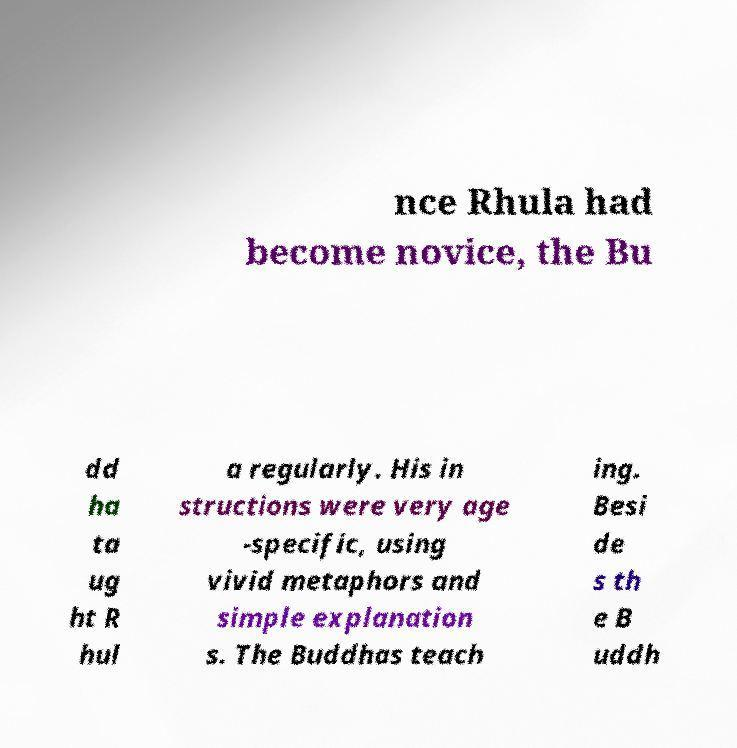Could you extract and type out the text from this image? nce Rhula had become novice, the Bu dd ha ta ug ht R hul a regularly. His in structions were very age -specific, using vivid metaphors and simple explanation s. The Buddhas teach ing. Besi de s th e B uddh 